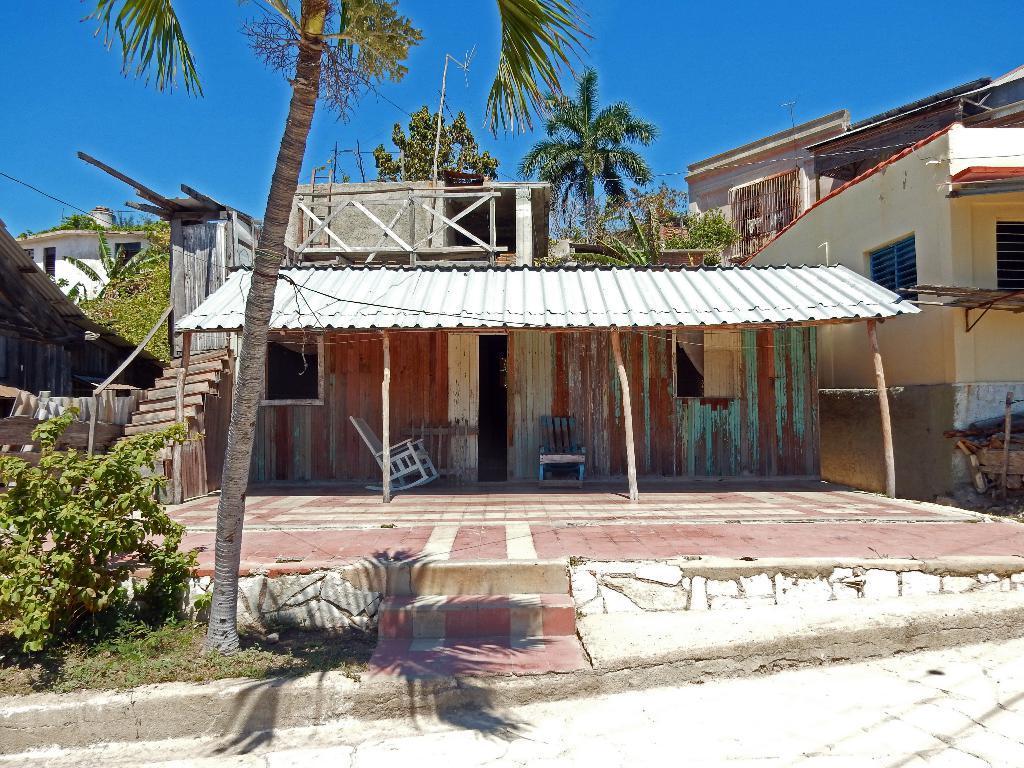How would you summarize this image in a sentence or two? This is an outside view. Here I can see few houses and trees. At the bottom there is a road. On the left side there are some plants. At the top of the image I can see the sky. 